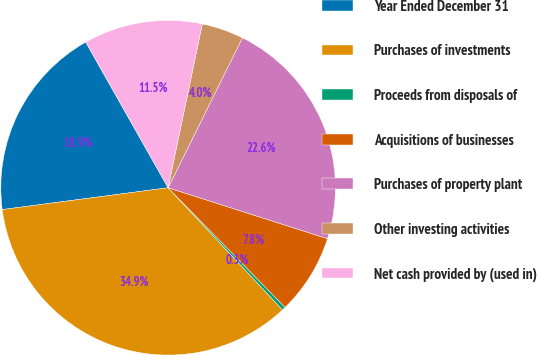<chart> <loc_0><loc_0><loc_500><loc_500><pie_chart><fcel>Year Ended December 31<fcel>Purchases of investments<fcel>Proceeds from disposals of<fcel>Acquisitions of businesses<fcel>Purchases of property plant<fcel>Other investing activities<fcel>Net cash provided by (used in)<nl><fcel>18.89%<fcel>34.9%<fcel>0.34%<fcel>7.76%<fcel>22.6%<fcel>4.05%<fcel>11.47%<nl></chart> 